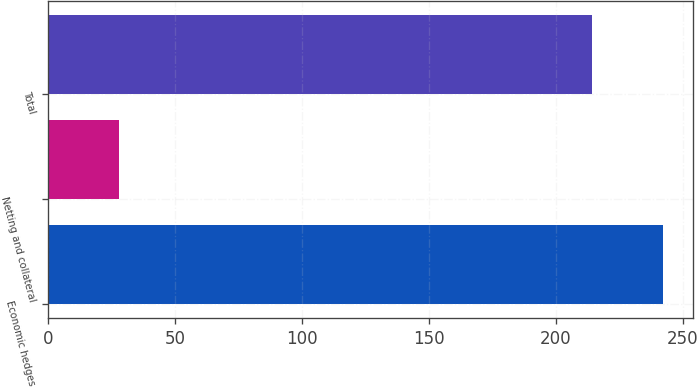<chart> <loc_0><loc_0><loc_500><loc_500><bar_chart><fcel>Economic hedges<fcel>Netting and collateral<fcel>Total<nl><fcel>242<fcel>28<fcel>214<nl></chart> 